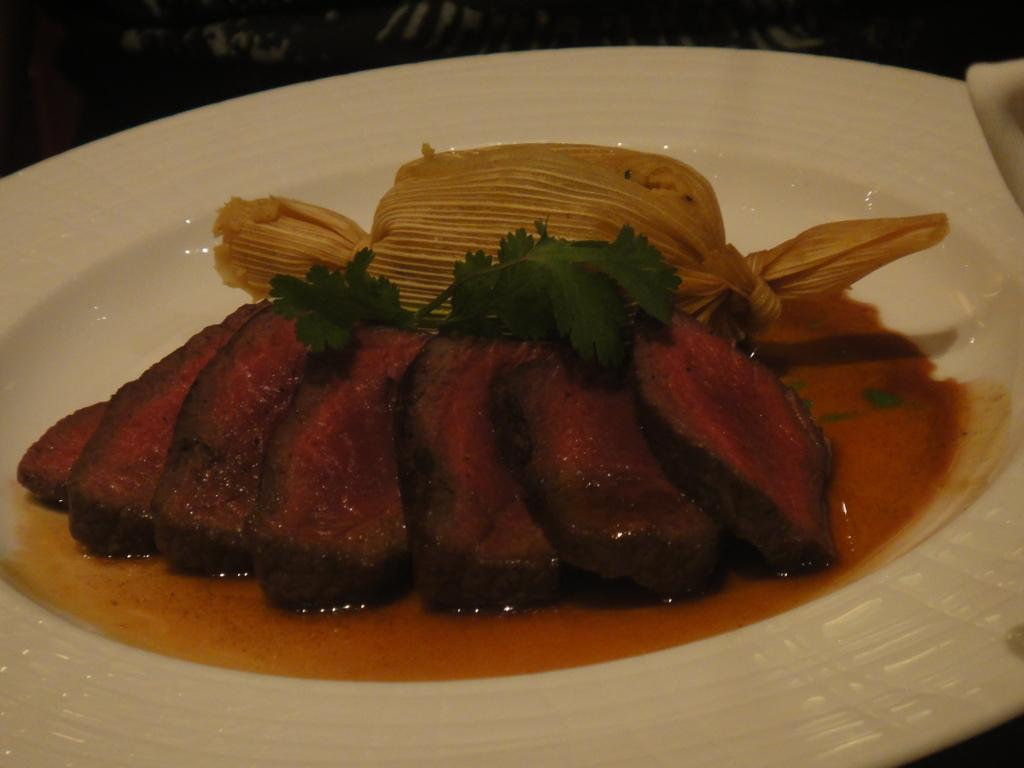What type of food can be seen in the image? There are fried fish pieces in the image. What herb is present with the food? Mint is present in the image. What substance is visible in the image? Oil is visible in the image. What other food items can be seen in the image? There are other food items in the image. What color is the plate on which the food is served? The plate is white. Where is the plate placed? The plate is kept on a table. How many horses are visible in the image? There are no horses present in the image. What type of boot is being used to prepare the food? There is no boot present in the image, and the food is not being prepared; it is already served on a plate. 